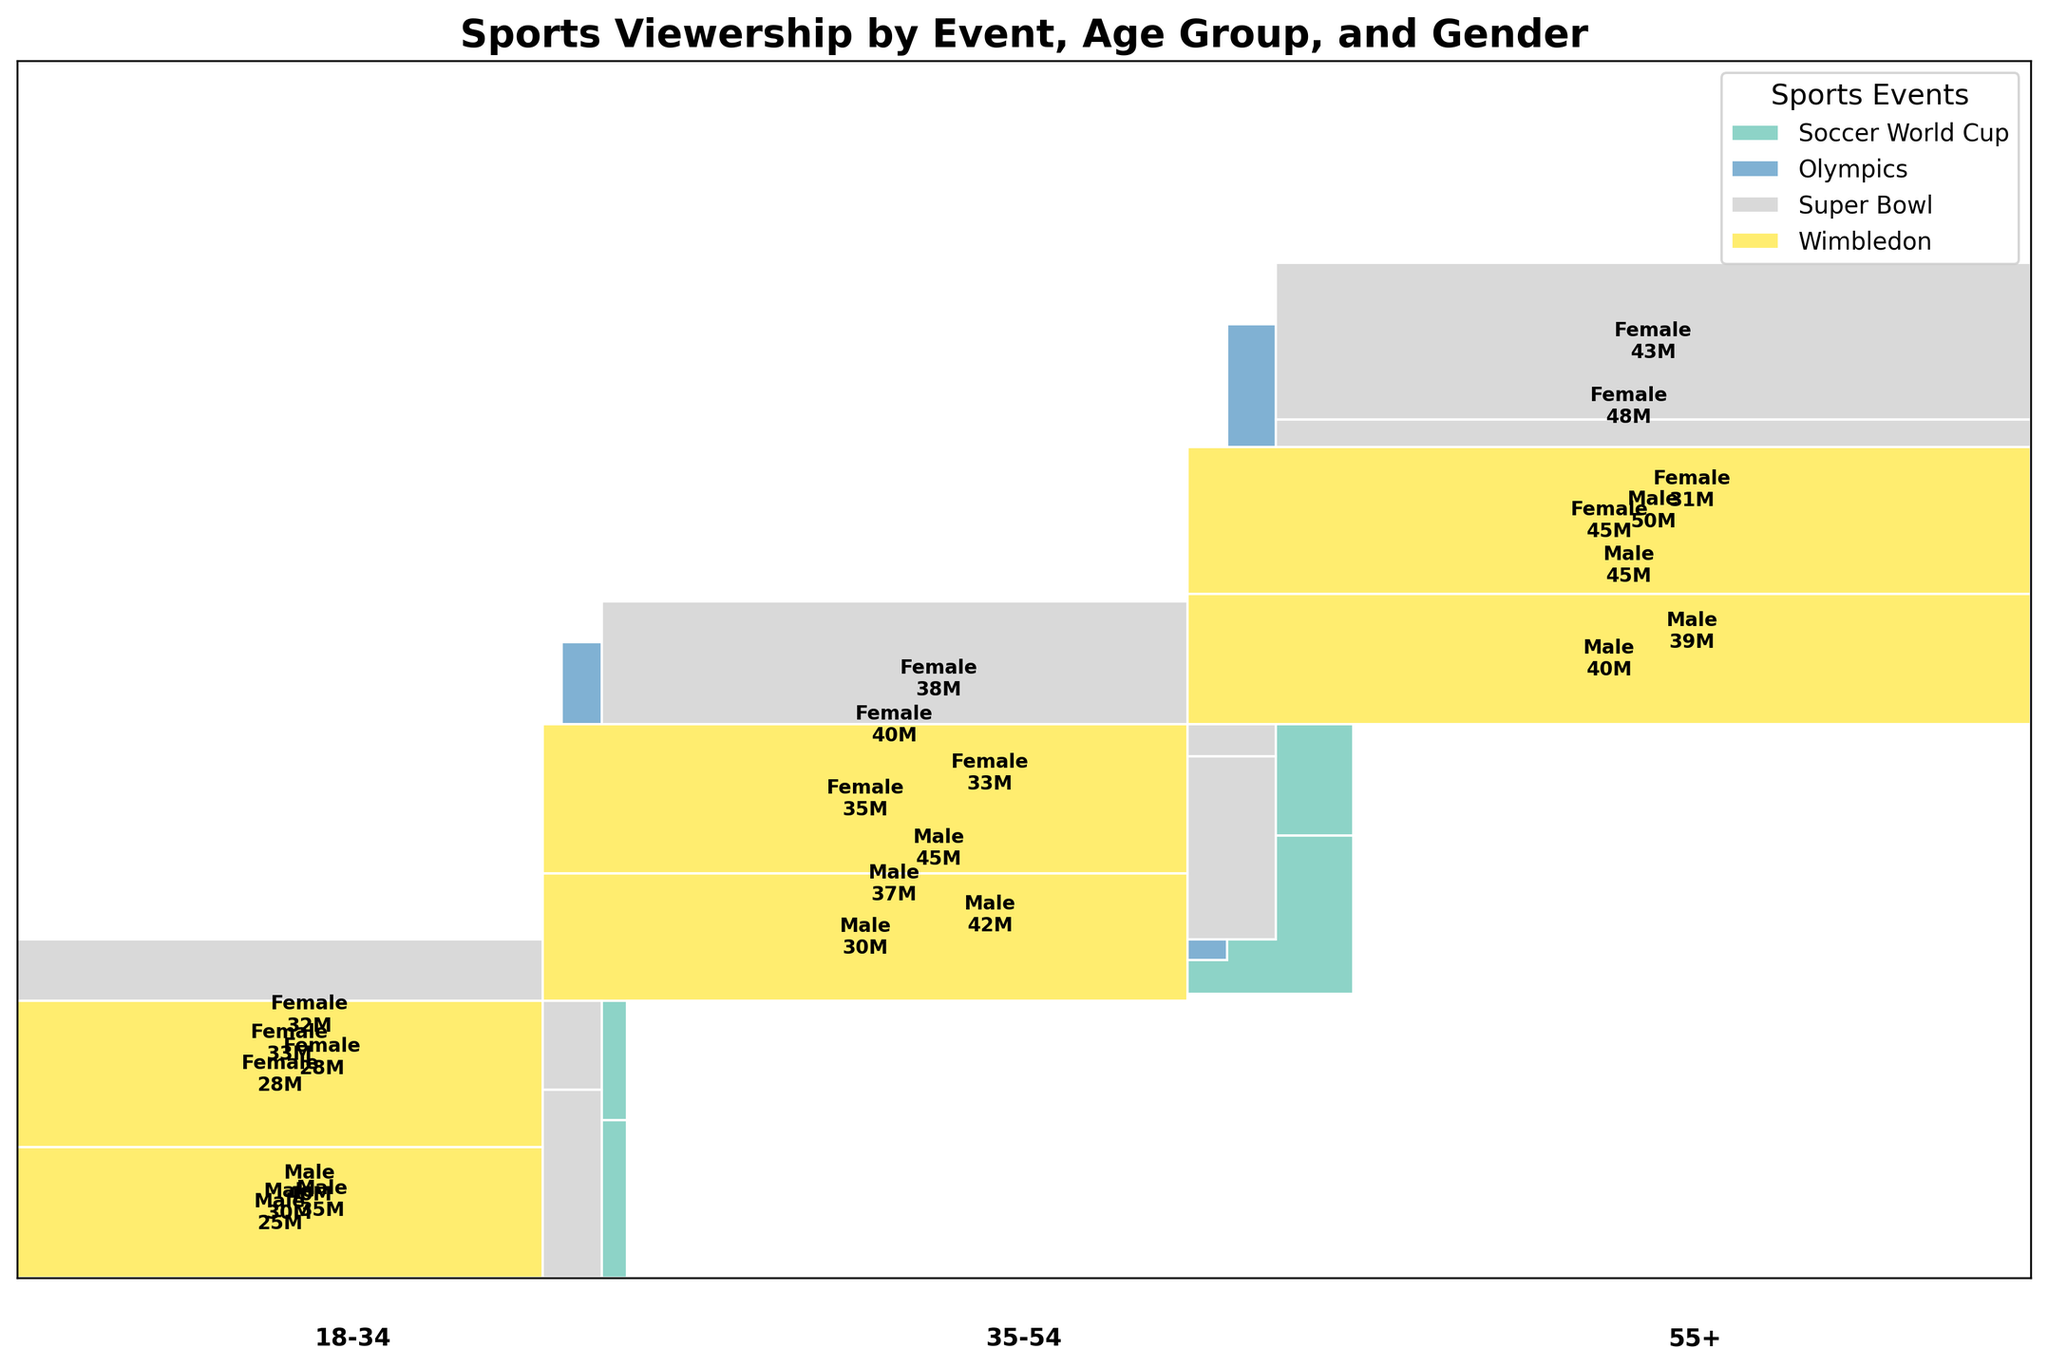What's the title of this plot? The title of the plot is written at the top center of the figure.
Answer: Sports Viewership by Event, Age Group, and Gender Which sport has the highest overall viewership? Each sport is represented by different colors in the mosaic plot, and the size of the area indicates the overall viewership.
Answer: Super Bowl How does the viewership of the Soccer World Cup in the 18-34 age group compare between males and females? Locate the Soccer World Cup section and compare the height of the rectangles for the 18-34 age group between males and females.
Answer: Males: 35M, Females: 28M Which age group has the highest female viewership for the Olympics? Look at the Olympics section and identify the highest rectangle corresponding to females in each age group.
Answer: 55+ What is the combined viewership of the Super Bowl for the 35-54 age group? To find the combined viewership for this age group, sum the viewership for males and females within this group.
Answer: 45M (Male) + 38M (Female) = 83M Between the 18-34 and 35-54 age groups, which has more male viewership for Wimbledon? Locate the Wimbledon section, then compare the rectangles for male viewership between the 18-34 and 35-54 age groups.
Answer: 35-54 Which gender holds a majority of the viewership in the 55+ age group for Soccer World Cup? In the Soccer World Cup section, compare the rectangles for males and females in the 55+ age group.
Answer: Male What's the overall trend in viewership as age increases for the Olympics? Observe the changes in the size of the rectangles for each subsequent age group in the Olympics section.
Answer: Increases with age Compare the total female viewership between the Super Bowl and Wimbledon. Sum the viewership for females across all age groups for both events and compare.
Answer: Super Bowl: 32M + 38M + 43M = 113M, Wimbledon: 28M + 35M + 45M = 108M Which age group has the lowest viewership across all sports? Look across all sports and age groups and identify the smallest rectangles.
Answer: 18-34 for Wimbledon 